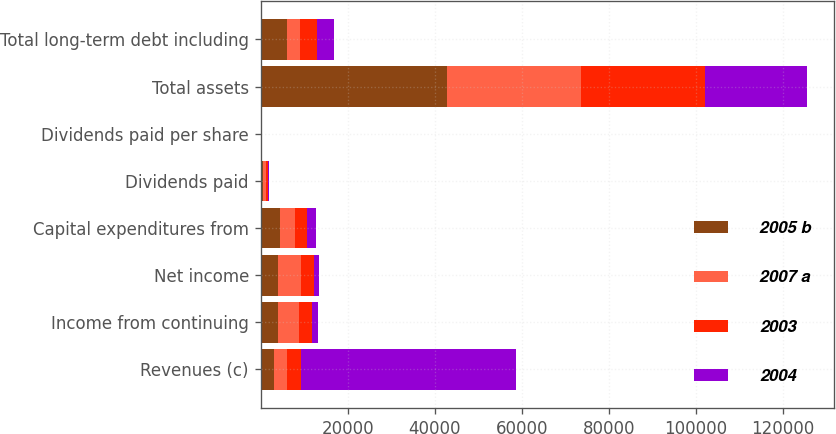Convert chart. <chart><loc_0><loc_0><loc_500><loc_500><stacked_bar_chart><ecel><fcel>Revenues (c)<fcel>Income from continuing<fcel>Net income<fcel>Capital expenditures from<fcel>Dividends paid<fcel>Dividends paid per share<fcel>Total assets<fcel>Total long-term debt including<nl><fcel>2005 b<fcel>3061<fcel>3948<fcel>3956<fcel>4466<fcel>637<fcel>0.92<fcel>42746<fcel>6084<nl><fcel>2007 a<fcel>3061<fcel>4957<fcel>5234<fcel>3433<fcel>547<fcel>0.76<fcel>30831<fcel>3061<nl><fcel>2003<fcel>3061<fcel>3006<fcel>3032<fcel>2796<fcel>436<fcel>0.6<fcel>28498<fcel>3698<nl><fcel>2004<fcel>49465<fcel>1294<fcel>1261<fcel>2141<fcel>348<fcel>0.51<fcel>23423<fcel>4057<nl></chart> 